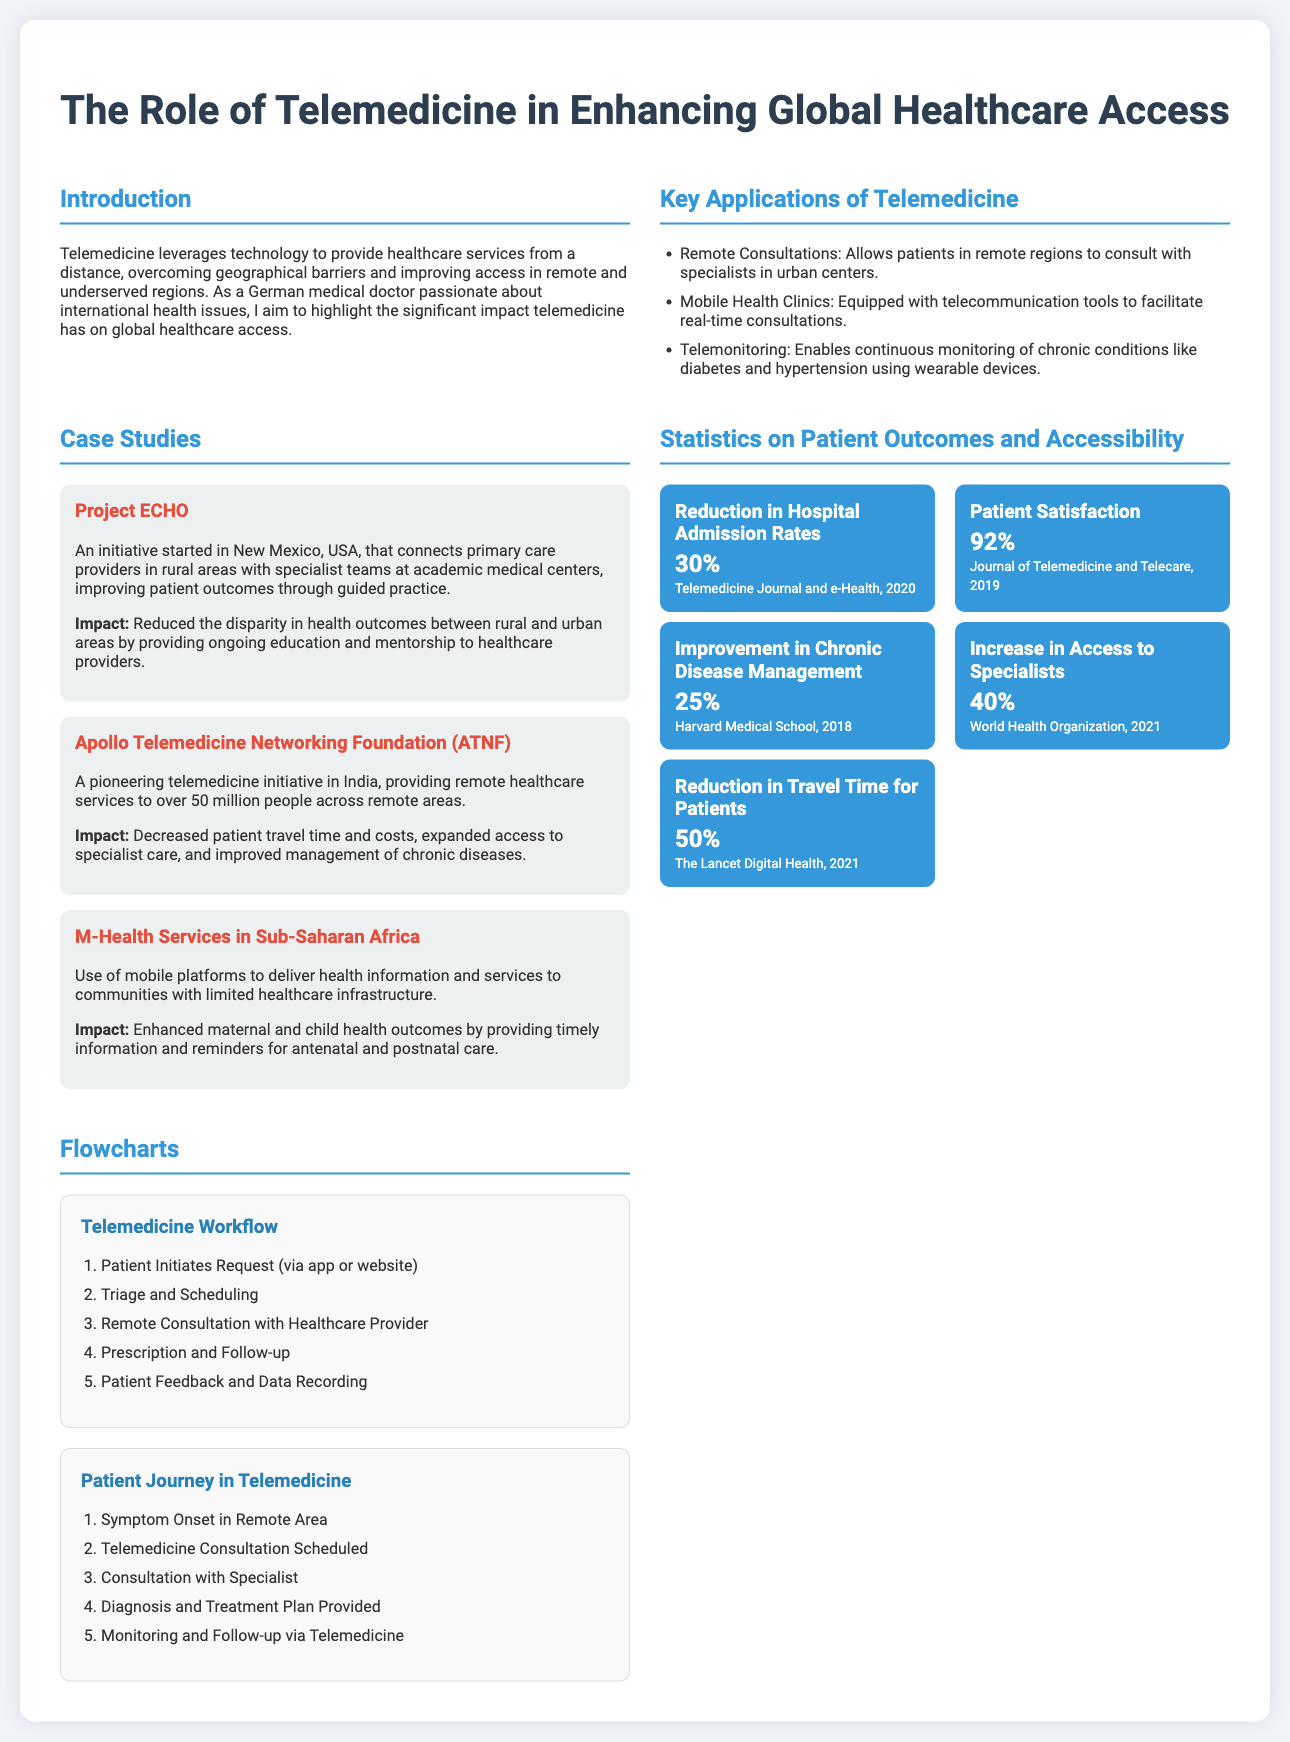What is the main focus of the poster? The main focus of the poster is on how telemedicine enhances global healthcare access.
Answer: Telemedicine enhances global healthcare access What is the satisfaction rate of patients using telemedicine? The satisfaction rate of patients is mentioned in the statistics section.
Answer: 92% What initiative connects primary care providers in rural areas with specialists? This information can be found in the case studies section, specifically about a successful project.
Answer: Project ECHO What percentage of travel time is reduced for patients using telemedicine? This statistic is included in the statistics section of the document.
Answer: 50% How has telemedicine affected hospital admission rates? This statistic is provided in the statistics section and indicates a notable change.
Answer: 30% What technology is vital for the consultation process in telemedicine? This is inferred from the key applications section discussing remote consultations.
Answer: Telecommunications What is a key application of telemedicine mentioned in the document? This information can be retrieved from the section discussing major applications.
Answer: Remote Consultations What is the impact of the Apollo Telemedicine Networking Foundation? The impact is described in the case studies section regarding its coverage and effects on remote population.
Answer: Improved management of chronic diseases What percentage increase in access to specialists does telemedicine provide? This statistic is cited in the statistics section of the document on access improvements.
Answer: 40% 